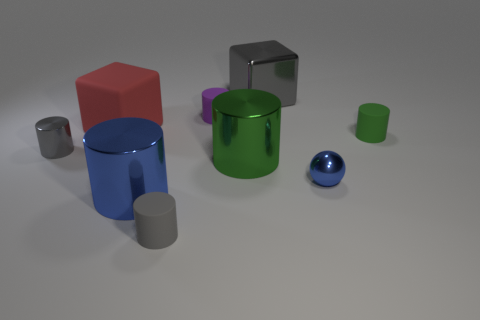Subtract all gray shiny cylinders. How many cylinders are left? 5 Subtract all green cylinders. How many cylinders are left? 4 Subtract all cubes. How many objects are left? 7 Add 8 tiny spheres. How many tiny spheres exist? 9 Subtract 1 red cubes. How many objects are left? 8 Subtract 1 blocks. How many blocks are left? 1 Subtract all purple blocks. Subtract all green balls. How many blocks are left? 2 Subtract all blue blocks. How many green cylinders are left? 2 Subtract all large things. Subtract all gray cubes. How many objects are left? 4 Add 5 big red cubes. How many big red cubes are left? 6 